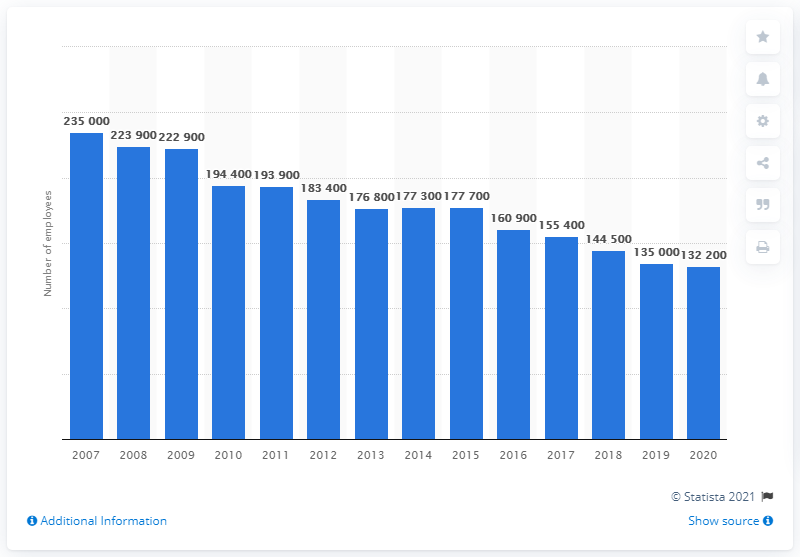List a handful of essential elements in this visual. In the year 2020, Verizon employed 132,200 people. 